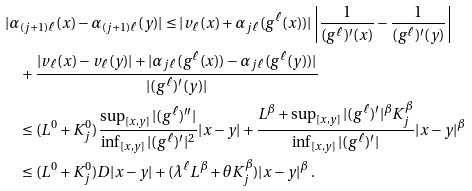<formula> <loc_0><loc_0><loc_500><loc_500>& | \alpha _ { ( j + 1 ) \ell } ( x ) - \alpha _ { ( j + 1 ) \ell } ( y ) | \leq | v _ { \ell } ( x ) + \alpha _ { j \ell } ( g ^ { \ell } ( x ) ) | \left | \frac { 1 } { ( g ^ { \ell } ) ^ { \prime } ( x ) } - \frac { 1 } { ( g ^ { \ell } ) ^ { \prime } ( y ) } \right | \\ & \quad + \frac { | v _ { \ell } ( x ) - v _ { \ell } ( y ) | + | \alpha _ { j \ell } ( g ^ { \ell } ( x ) ) - \alpha _ { j \ell } ( g ^ { \ell } ( y ) ) | } { | ( g ^ { \ell } ) ^ { \prime } ( y ) | } \\ & \quad \leq ( L ^ { 0 } + K ^ { 0 } _ { j } ) \frac { \sup _ { [ x , y ] } | ( g ^ { \ell } ) ^ { \prime \prime } | } { \inf _ { [ x , y ] } | ( g ^ { \ell } ) ^ { \prime } | ^ { 2 } } | x - y | + \frac { L ^ { \beta } + \sup _ { [ x , y ] } | ( g ^ { \ell } ) ^ { \prime } | ^ { \beta } K _ { j } ^ { \beta } } { \inf _ { [ x , y ] } | ( g ^ { \ell } ) ^ { \prime } | } | x - y | ^ { \beta } \\ & \quad \leq ( L ^ { 0 } + K ^ { 0 } _ { j } ) D | x - y | + ( \lambda ^ { \ell } L ^ { \beta } + \theta K _ { j } ^ { \beta } ) | x - y | ^ { \beta } \, .</formula> 